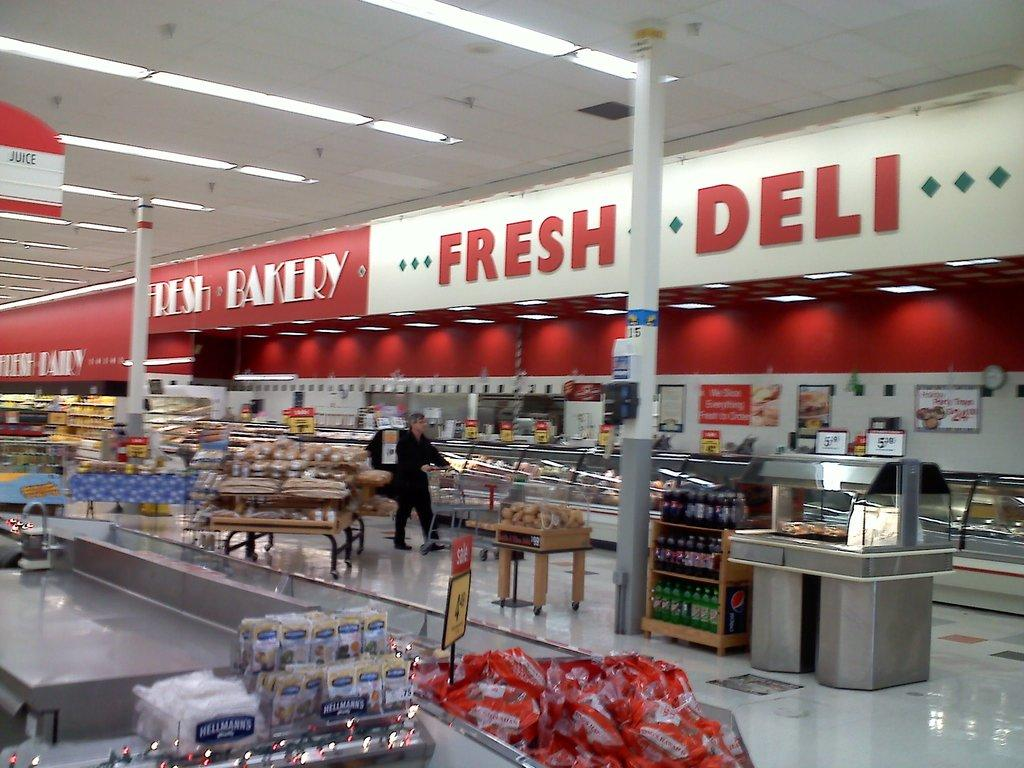<image>
Share a concise interpretation of the image provided. Fresh Deli and Fresh Bakery are written in opposing color schemes at this grocery store. 